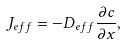Convert formula to latex. <formula><loc_0><loc_0><loc_500><loc_500>J _ { e f f } = - D _ { e f f } \frac { \partial c } { \partial x } ,</formula> 